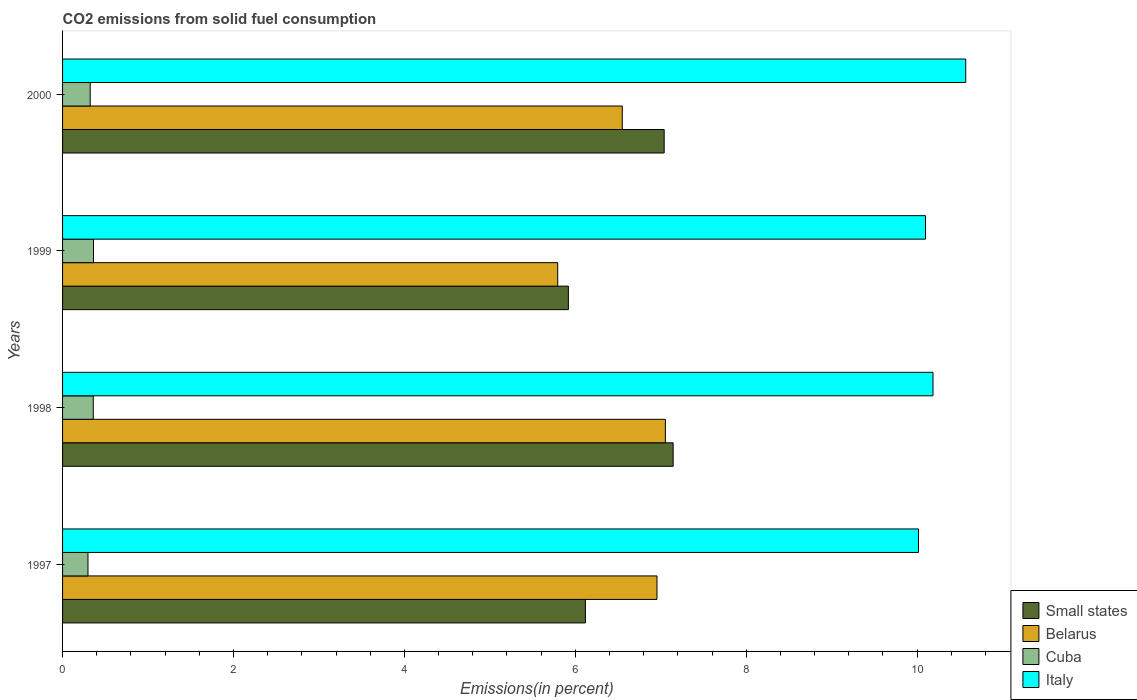How many different coloured bars are there?
Make the answer very short. 4. Are the number of bars on each tick of the Y-axis equal?
Your answer should be compact. Yes. How many bars are there on the 1st tick from the bottom?
Make the answer very short. 4. What is the total CO2 emitted in Cuba in 2000?
Offer a terse response. 0.32. Across all years, what is the maximum total CO2 emitted in Cuba?
Provide a succinct answer. 0.36. Across all years, what is the minimum total CO2 emitted in Small states?
Offer a very short reply. 5.92. In which year was the total CO2 emitted in Belarus minimum?
Provide a short and direct response. 1999. What is the total total CO2 emitted in Italy in the graph?
Make the answer very short. 40.87. What is the difference between the total CO2 emitted in Italy in 1997 and that in 1999?
Your answer should be compact. -0.08. What is the difference between the total CO2 emitted in Italy in 1998 and the total CO2 emitted in Belarus in 1997?
Your response must be concise. 3.23. What is the average total CO2 emitted in Italy per year?
Your response must be concise. 10.22. In the year 1998, what is the difference between the total CO2 emitted in Small states and total CO2 emitted in Cuba?
Your answer should be very brief. 6.79. In how many years, is the total CO2 emitted in Italy greater than 4.8 %?
Offer a very short reply. 4. What is the ratio of the total CO2 emitted in Italy in 1999 to that in 2000?
Your response must be concise. 0.96. What is the difference between the highest and the second highest total CO2 emitted in Cuba?
Give a very brief answer. 0. What is the difference between the highest and the lowest total CO2 emitted in Belarus?
Provide a short and direct response. 1.26. Is the sum of the total CO2 emitted in Italy in 1998 and 1999 greater than the maximum total CO2 emitted in Small states across all years?
Provide a short and direct response. Yes. Is it the case that in every year, the sum of the total CO2 emitted in Italy and total CO2 emitted in Cuba is greater than the sum of total CO2 emitted in Belarus and total CO2 emitted in Small states?
Your answer should be compact. Yes. What does the 4th bar from the top in 1998 represents?
Provide a short and direct response. Small states. What does the 4th bar from the bottom in 1997 represents?
Your answer should be very brief. Italy. Is it the case that in every year, the sum of the total CO2 emitted in Cuba and total CO2 emitted in Belarus is greater than the total CO2 emitted in Small states?
Ensure brevity in your answer.  No. How many bars are there?
Your response must be concise. 16. How many years are there in the graph?
Your response must be concise. 4. Are the values on the major ticks of X-axis written in scientific E-notation?
Your answer should be compact. No. Does the graph contain any zero values?
Keep it short and to the point. No. Where does the legend appear in the graph?
Offer a very short reply. Bottom right. How many legend labels are there?
Your response must be concise. 4. How are the legend labels stacked?
Provide a short and direct response. Vertical. What is the title of the graph?
Your response must be concise. CO2 emissions from solid fuel consumption. Does "Guyana" appear as one of the legend labels in the graph?
Provide a succinct answer. No. What is the label or title of the X-axis?
Provide a succinct answer. Emissions(in percent). What is the Emissions(in percent) in Small states in 1997?
Give a very brief answer. 6.12. What is the Emissions(in percent) in Belarus in 1997?
Your answer should be compact. 6.96. What is the Emissions(in percent) in Cuba in 1997?
Give a very brief answer. 0.3. What is the Emissions(in percent) in Italy in 1997?
Offer a terse response. 10.02. What is the Emissions(in percent) in Small states in 1998?
Provide a succinct answer. 7.14. What is the Emissions(in percent) of Belarus in 1998?
Give a very brief answer. 7.05. What is the Emissions(in percent) in Cuba in 1998?
Ensure brevity in your answer.  0.36. What is the Emissions(in percent) of Italy in 1998?
Make the answer very short. 10.19. What is the Emissions(in percent) of Small states in 1999?
Ensure brevity in your answer.  5.92. What is the Emissions(in percent) of Belarus in 1999?
Give a very brief answer. 5.79. What is the Emissions(in percent) in Cuba in 1999?
Ensure brevity in your answer.  0.36. What is the Emissions(in percent) of Italy in 1999?
Offer a very short reply. 10.1. What is the Emissions(in percent) in Small states in 2000?
Ensure brevity in your answer.  7.04. What is the Emissions(in percent) in Belarus in 2000?
Provide a succinct answer. 6.55. What is the Emissions(in percent) of Cuba in 2000?
Keep it short and to the point. 0.32. What is the Emissions(in percent) of Italy in 2000?
Offer a very short reply. 10.57. Across all years, what is the maximum Emissions(in percent) in Small states?
Ensure brevity in your answer.  7.14. Across all years, what is the maximum Emissions(in percent) in Belarus?
Give a very brief answer. 7.05. Across all years, what is the maximum Emissions(in percent) in Cuba?
Your answer should be very brief. 0.36. Across all years, what is the maximum Emissions(in percent) of Italy?
Provide a succinct answer. 10.57. Across all years, what is the minimum Emissions(in percent) of Small states?
Give a very brief answer. 5.92. Across all years, what is the minimum Emissions(in percent) of Belarus?
Your response must be concise. 5.79. Across all years, what is the minimum Emissions(in percent) in Cuba?
Your answer should be very brief. 0.3. Across all years, what is the minimum Emissions(in percent) in Italy?
Keep it short and to the point. 10.02. What is the total Emissions(in percent) in Small states in the graph?
Your response must be concise. 26.22. What is the total Emissions(in percent) in Belarus in the graph?
Keep it short and to the point. 26.35. What is the total Emissions(in percent) of Cuba in the graph?
Make the answer very short. 1.34. What is the total Emissions(in percent) in Italy in the graph?
Your answer should be compact. 40.87. What is the difference between the Emissions(in percent) of Small states in 1997 and that in 1998?
Your answer should be compact. -1.03. What is the difference between the Emissions(in percent) in Belarus in 1997 and that in 1998?
Make the answer very short. -0.1. What is the difference between the Emissions(in percent) of Cuba in 1997 and that in 1998?
Make the answer very short. -0.06. What is the difference between the Emissions(in percent) in Italy in 1997 and that in 1998?
Your answer should be very brief. -0.17. What is the difference between the Emissions(in percent) in Small states in 1997 and that in 1999?
Offer a terse response. 0.2. What is the difference between the Emissions(in percent) in Belarus in 1997 and that in 1999?
Make the answer very short. 1.16. What is the difference between the Emissions(in percent) in Cuba in 1997 and that in 1999?
Give a very brief answer. -0.06. What is the difference between the Emissions(in percent) in Italy in 1997 and that in 1999?
Provide a short and direct response. -0.08. What is the difference between the Emissions(in percent) in Small states in 1997 and that in 2000?
Offer a very short reply. -0.92. What is the difference between the Emissions(in percent) of Belarus in 1997 and that in 2000?
Make the answer very short. 0.41. What is the difference between the Emissions(in percent) in Cuba in 1997 and that in 2000?
Your answer should be very brief. -0.03. What is the difference between the Emissions(in percent) of Italy in 1997 and that in 2000?
Ensure brevity in your answer.  -0.55. What is the difference between the Emissions(in percent) in Small states in 1998 and that in 1999?
Make the answer very short. 1.23. What is the difference between the Emissions(in percent) in Belarus in 1998 and that in 1999?
Your response must be concise. 1.26. What is the difference between the Emissions(in percent) of Cuba in 1998 and that in 1999?
Your answer should be compact. -0. What is the difference between the Emissions(in percent) of Italy in 1998 and that in 1999?
Ensure brevity in your answer.  0.09. What is the difference between the Emissions(in percent) of Small states in 1998 and that in 2000?
Provide a short and direct response. 0.1. What is the difference between the Emissions(in percent) of Belarus in 1998 and that in 2000?
Provide a short and direct response. 0.5. What is the difference between the Emissions(in percent) of Cuba in 1998 and that in 2000?
Your response must be concise. 0.04. What is the difference between the Emissions(in percent) of Italy in 1998 and that in 2000?
Make the answer very short. -0.38. What is the difference between the Emissions(in percent) of Small states in 1999 and that in 2000?
Your answer should be compact. -1.12. What is the difference between the Emissions(in percent) in Belarus in 1999 and that in 2000?
Your answer should be compact. -0.76. What is the difference between the Emissions(in percent) of Cuba in 1999 and that in 2000?
Your answer should be very brief. 0.04. What is the difference between the Emissions(in percent) of Italy in 1999 and that in 2000?
Provide a short and direct response. -0.47. What is the difference between the Emissions(in percent) in Small states in 1997 and the Emissions(in percent) in Belarus in 1998?
Make the answer very short. -0.94. What is the difference between the Emissions(in percent) in Small states in 1997 and the Emissions(in percent) in Cuba in 1998?
Provide a succinct answer. 5.76. What is the difference between the Emissions(in percent) of Small states in 1997 and the Emissions(in percent) of Italy in 1998?
Ensure brevity in your answer.  -4.07. What is the difference between the Emissions(in percent) in Belarus in 1997 and the Emissions(in percent) in Cuba in 1998?
Your answer should be very brief. 6.6. What is the difference between the Emissions(in percent) in Belarus in 1997 and the Emissions(in percent) in Italy in 1998?
Offer a terse response. -3.23. What is the difference between the Emissions(in percent) of Cuba in 1997 and the Emissions(in percent) of Italy in 1998?
Your response must be concise. -9.89. What is the difference between the Emissions(in percent) in Small states in 1997 and the Emissions(in percent) in Belarus in 1999?
Your response must be concise. 0.32. What is the difference between the Emissions(in percent) of Small states in 1997 and the Emissions(in percent) of Cuba in 1999?
Keep it short and to the point. 5.76. What is the difference between the Emissions(in percent) in Small states in 1997 and the Emissions(in percent) in Italy in 1999?
Keep it short and to the point. -3.98. What is the difference between the Emissions(in percent) in Belarus in 1997 and the Emissions(in percent) in Cuba in 1999?
Provide a succinct answer. 6.59. What is the difference between the Emissions(in percent) of Belarus in 1997 and the Emissions(in percent) of Italy in 1999?
Your answer should be very brief. -3.14. What is the difference between the Emissions(in percent) of Cuba in 1997 and the Emissions(in percent) of Italy in 1999?
Ensure brevity in your answer.  -9.8. What is the difference between the Emissions(in percent) in Small states in 1997 and the Emissions(in percent) in Belarus in 2000?
Your answer should be very brief. -0.43. What is the difference between the Emissions(in percent) of Small states in 1997 and the Emissions(in percent) of Cuba in 2000?
Your answer should be very brief. 5.79. What is the difference between the Emissions(in percent) of Small states in 1997 and the Emissions(in percent) of Italy in 2000?
Offer a very short reply. -4.45. What is the difference between the Emissions(in percent) in Belarus in 1997 and the Emissions(in percent) in Cuba in 2000?
Keep it short and to the point. 6.63. What is the difference between the Emissions(in percent) of Belarus in 1997 and the Emissions(in percent) of Italy in 2000?
Your answer should be very brief. -3.61. What is the difference between the Emissions(in percent) in Cuba in 1997 and the Emissions(in percent) in Italy in 2000?
Offer a terse response. -10.27. What is the difference between the Emissions(in percent) of Small states in 1998 and the Emissions(in percent) of Belarus in 1999?
Provide a short and direct response. 1.35. What is the difference between the Emissions(in percent) in Small states in 1998 and the Emissions(in percent) in Cuba in 1999?
Provide a short and direct response. 6.78. What is the difference between the Emissions(in percent) in Small states in 1998 and the Emissions(in percent) in Italy in 1999?
Offer a terse response. -2.95. What is the difference between the Emissions(in percent) in Belarus in 1998 and the Emissions(in percent) in Cuba in 1999?
Provide a short and direct response. 6.69. What is the difference between the Emissions(in percent) of Belarus in 1998 and the Emissions(in percent) of Italy in 1999?
Offer a terse response. -3.04. What is the difference between the Emissions(in percent) in Cuba in 1998 and the Emissions(in percent) in Italy in 1999?
Your answer should be compact. -9.74. What is the difference between the Emissions(in percent) of Small states in 1998 and the Emissions(in percent) of Belarus in 2000?
Provide a short and direct response. 0.6. What is the difference between the Emissions(in percent) in Small states in 1998 and the Emissions(in percent) in Cuba in 2000?
Make the answer very short. 6.82. What is the difference between the Emissions(in percent) of Small states in 1998 and the Emissions(in percent) of Italy in 2000?
Give a very brief answer. -3.42. What is the difference between the Emissions(in percent) in Belarus in 1998 and the Emissions(in percent) in Cuba in 2000?
Your response must be concise. 6.73. What is the difference between the Emissions(in percent) in Belarus in 1998 and the Emissions(in percent) in Italy in 2000?
Your response must be concise. -3.51. What is the difference between the Emissions(in percent) of Cuba in 1998 and the Emissions(in percent) of Italy in 2000?
Your answer should be compact. -10.21. What is the difference between the Emissions(in percent) in Small states in 1999 and the Emissions(in percent) in Belarus in 2000?
Your answer should be very brief. -0.63. What is the difference between the Emissions(in percent) of Small states in 1999 and the Emissions(in percent) of Cuba in 2000?
Your answer should be very brief. 5.6. What is the difference between the Emissions(in percent) in Small states in 1999 and the Emissions(in percent) in Italy in 2000?
Your answer should be very brief. -4.65. What is the difference between the Emissions(in percent) of Belarus in 1999 and the Emissions(in percent) of Cuba in 2000?
Make the answer very short. 5.47. What is the difference between the Emissions(in percent) of Belarus in 1999 and the Emissions(in percent) of Italy in 2000?
Keep it short and to the point. -4.77. What is the difference between the Emissions(in percent) in Cuba in 1999 and the Emissions(in percent) in Italy in 2000?
Offer a very short reply. -10.21. What is the average Emissions(in percent) in Small states per year?
Ensure brevity in your answer.  6.56. What is the average Emissions(in percent) in Belarus per year?
Offer a terse response. 6.59. What is the average Emissions(in percent) of Cuba per year?
Your answer should be very brief. 0.34. What is the average Emissions(in percent) of Italy per year?
Offer a terse response. 10.22. In the year 1997, what is the difference between the Emissions(in percent) of Small states and Emissions(in percent) of Belarus?
Your answer should be compact. -0.84. In the year 1997, what is the difference between the Emissions(in percent) in Small states and Emissions(in percent) in Cuba?
Your answer should be very brief. 5.82. In the year 1997, what is the difference between the Emissions(in percent) of Small states and Emissions(in percent) of Italy?
Your response must be concise. -3.9. In the year 1997, what is the difference between the Emissions(in percent) of Belarus and Emissions(in percent) of Cuba?
Make the answer very short. 6.66. In the year 1997, what is the difference between the Emissions(in percent) of Belarus and Emissions(in percent) of Italy?
Your answer should be very brief. -3.06. In the year 1997, what is the difference between the Emissions(in percent) of Cuba and Emissions(in percent) of Italy?
Keep it short and to the point. -9.72. In the year 1998, what is the difference between the Emissions(in percent) in Small states and Emissions(in percent) in Belarus?
Give a very brief answer. 0.09. In the year 1998, what is the difference between the Emissions(in percent) in Small states and Emissions(in percent) in Cuba?
Offer a very short reply. 6.79. In the year 1998, what is the difference between the Emissions(in percent) of Small states and Emissions(in percent) of Italy?
Your answer should be very brief. -3.04. In the year 1998, what is the difference between the Emissions(in percent) in Belarus and Emissions(in percent) in Cuba?
Your answer should be compact. 6.7. In the year 1998, what is the difference between the Emissions(in percent) in Belarus and Emissions(in percent) in Italy?
Make the answer very short. -3.13. In the year 1998, what is the difference between the Emissions(in percent) of Cuba and Emissions(in percent) of Italy?
Keep it short and to the point. -9.83. In the year 1999, what is the difference between the Emissions(in percent) in Small states and Emissions(in percent) in Belarus?
Your answer should be very brief. 0.12. In the year 1999, what is the difference between the Emissions(in percent) of Small states and Emissions(in percent) of Cuba?
Provide a short and direct response. 5.56. In the year 1999, what is the difference between the Emissions(in percent) in Small states and Emissions(in percent) in Italy?
Ensure brevity in your answer.  -4.18. In the year 1999, what is the difference between the Emissions(in percent) in Belarus and Emissions(in percent) in Cuba?
Provide a succinct answer. 5.43. In the year 1999, what is the difference between the Emissions(in percent) in Belarus and Emissions(in percent) in Italy?
Keep it short and to the point. -4.3. In the year 1999, what is the difference between the Emissions(in percent) of Cuba and Emissions(in percent) of Italy?
Offer a terse response. -9.74. In the year 2000, what is the difference between the Emissions(in percent) in Small states and Emissions(in percent) in Belarus?
Give a very brief answer. 0.49. In the year 2000, what is the difference between the Emissions(in percent) of Small states and Emissions(in percent) of Cuba?
Provide a succinct answer. 6.72. In the year 2000, what is the difference between the Emissions(in percent) of Small states and Emissions(in percent) of Italy?
Your answer should be very brief. -3.53. In the year 2000, what is the difference between the Emissions(in percent) in Belarus and Emissions(in percent) in Cuba?
Provide a short and direct response. 6.23. In the year 2000, what is the difference between the Emissions(in percent) in Belarus and Emissions(in percent) in Italy?
Your answer should be compact. -4.02. In the year 2000, what is the difference between the Emissions(in percent) of Cuba and Emissions(in percent) of Italy?
Provide a short and direct response. -10.25. What is the ratio of the Emissions(in percent) of Small states in 1997 to that in 1998?
Ensure brevity in your answer.  0.86. What is the ratio of the Emissions(in percent) of Belarus in 1997 to that in 1998?
Give a very brief answer. 0.99. What is the ratio of the Emissions(in percent) in Cuba in 1997 to that in 1998?
Provide a succinct answer. 0.83. What is the ratio of the Emissions(in percent) of Italy in 1997 to that in 1998?
Your response must be concise. 0.98. What is the ratio of the Emissions(in percent) in Small states in 1997 to that in 1999?
Offer a terse response. 1.03. What is the ratio of the Emissions(in percent) in Belarus in 1997 to that in 1999?
Your answer should be very brief. 1.2. What is the ratio of the Emissions(in percent) in Cuba in 1997 to that in 1999?
Make the answer very short. 0.82. What is the ratio of the Emissions(in percent) in Italy in 1997 to that in 1999?
Provide a short and direct response. 0.99. What is the ratio of the Emissions(in percent) in Small states in 1997 to that in 2000?
Your answer should be compact. 0.87. What is the ratio of the Emissions(in percent) of Belarus in 1997 to that in 2000?
Your answer should be very brief. 1.06. What is the ratio of the Emissions(in percent) in Cuba in 1997 to that in 2000?
Your answer should be very brief. 0.92. What is the ratio of the Emissions(in percent) of Italy in 1997 to that in 2000?
Offer a very short reply. 0.95. What is the ratio of the Emissions(in percent) of Small states in 1998 to that in 1999?
Keep it short and to the point. 1.21. What is the ratio of the Emissions(in percent) in Belarus in 1998 to that in 1999?
Offer a very short reply. 1.22. What is the ratio of the Emissions(in percent) of Cuba in 1998 to that in 1999?
Offer a terse response. 0.99. What is the ratio of the Emissions(in percent) in Italy in 1998 to that in 1999?
Your response must be concise. 1.01. What is the ratio of the Emissions(in percent) of Small states in 1998 to that in 2000?
Provide a short and direct response. 1.01. What is the ratio of the Emissions(in percent) of Belarus in 1998 to that in 2000?
Offer a very short reply. 1.08. What is the ratio of the Emissions(in percent) in Cuba in 1998 to that in 2000?
Keep it short and to the point. 1.11. What is the ratio of the Emissions(in percent) in Italy in 1998 to that in 2000?
Offer a very short reply. 0.96. What is the ratio of the Emissions(in percent) in Small states in 1999 to that in 2000?
Make the answer very short. 0.84. What is the ratio of the Emissions(in percent) in Belarus in 1999 to that in 2000?
Give a very brief answer. 0.88. What is the ratio of the Emissions(in percent) of Cuba in 1999 to that in 2000?
Make the answer very short. 1.12. What is the ratio of the Emissions(in percent) in Italy in 1999 to that in 2000?
Your response must be concise. 0.96. What is the difference between the highest and the second highest Emissions(in percent) in Small states?
Your answer should be very brief. 0.1. What is the difference between the highest and the second highest Emissions(in percent) in Belarus?
Give a very brief answer. 0.1. What is the difference between the highest and the second highest Emissions(in percent) in Cuba?
Offer a very short reply. 0. What is the difference between the highest and the second highest Emissions(in percent) in Italy?
Offer a very short reply. 0.38. What is the difference between the highest and the lowest Emissions(in percent) of Small states?
Give a very brief answer. 1.23. What is the difference between the highest and the lowest Emissions(in percent) in Belarus?
Offer a very short reply. 1.26. What is the difference between the highest and the lowest Emissions(in percent) in Cuba?
Your response must be concise. 0.06. What is the difference between the highest and the lowest Emissions(in percent) in Italy?
Offer a very short reply. 0.55. 